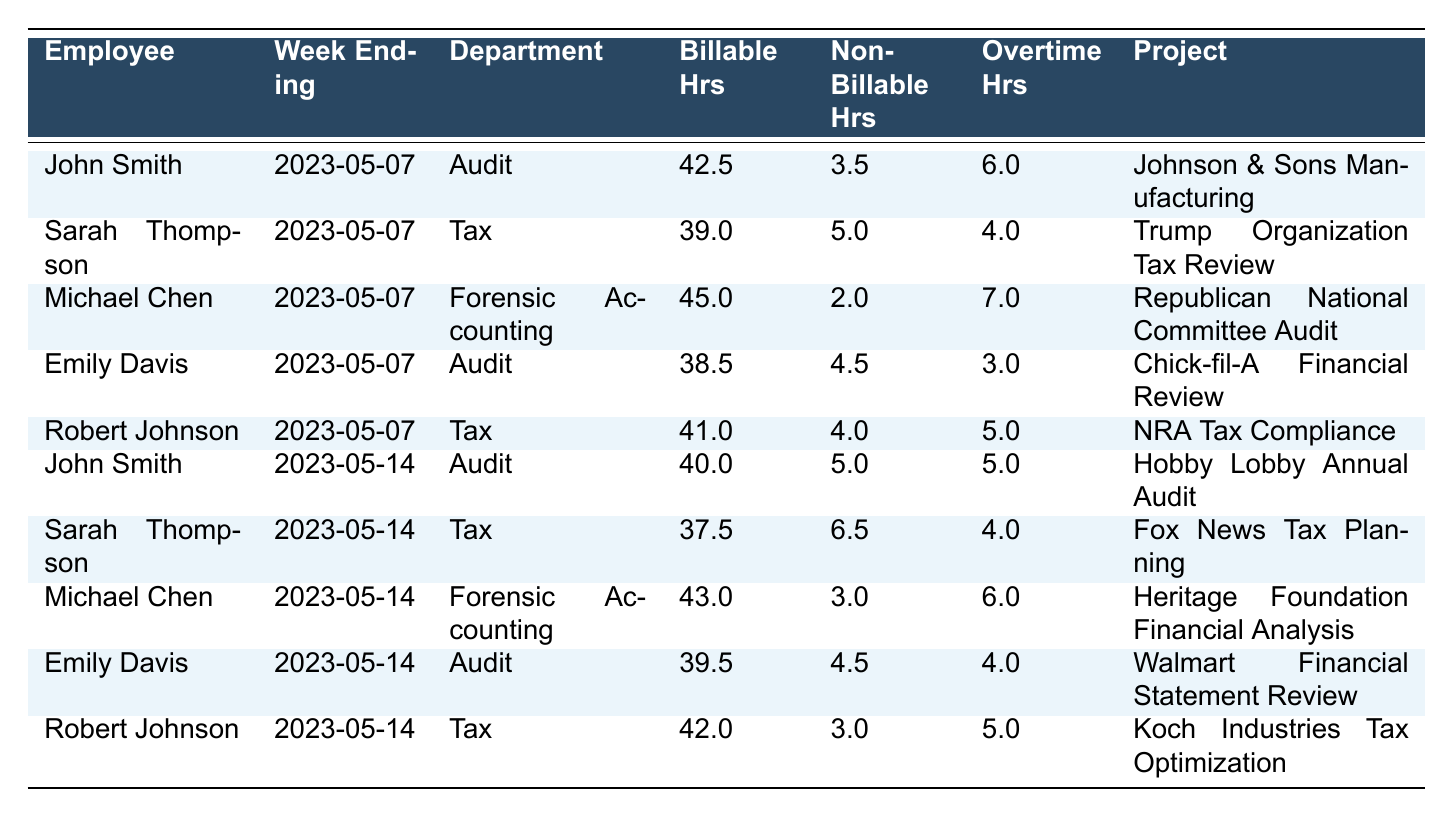What is the total number of billable hours for John Smith across both weeks? From the table, John Smith's billable hours for the week ending on May 7 is 42.5, and for the week ending on May 14, it is 40.0. Adding these together gives us 42.5 + 40.0 = 82.5.
Answer: 82.5 Which employee worked the most non-billable hours in the week ending May 7? Looking at the table for the week ending May 7, the non-billable hours for each employee are as follows: John Smith with 3.5, Sarah Thompson with 5.0, Michael Chen with 2.0, Emily Davis with 4.5, and Robert Johnson with 4.0. The highest non-billable hours is 5.0 by Sarah Thompson.
Answer: Sarah Thompson What is the overtime hour difference between Michael Chen and Robert Johnson for the week ending May 14? In the week ending May 14, Michael Chen has 6.0 overtime hours and Robert Johnson has 5.0. The difference is calculated as 6.0 - 5.0 = 1.0.
Answer: 1.0 On which project did Emily Davis work the least billable hours? Emily Davis worked on two projects: Chick-fil-A Financial Review with 38.5 billable hours and Walmart Financial Statement Review with 39.5 billable hours. Since 38.5 is less than 39.5, she worked the least hours on Chick-fil-A Financial Review.
Answer: Chick-fil-A Financial Review Are the total number of billable hours for Sarah Thompson in both weeks greater than that of Robert Johnson? Sarah Thompson's total billable hours are 39.0 (week ending May 7) + 37.5 (week ending May 14) = 76.5. Robert Johnson's total is 41.0 (week ending May 7) + 42.0 (week ending May 14) = 83.0. Comparing these totals shows that 76.5 is less than 83.0, so the statement is false.
Answer: No What is the average billable hours for the employees in the Audit department over both weeks? For the Audit department, the billable hours over both weeks are: John Smith with 42.5 and 40.0, Emily Davis with 38.5 and 39.5. The total is 42.5 + 40.0 + 38.5 + 39.5 = 160.0. There are four entries, so the average is 160.0 / 4 = 40.0.
Answer: 40.0 What is the total overtime hours worked by all employees in the Tax department over the two weeks? For the week ending May 7, Sarah Thompson has 4.0 overtime hours and Robert Johnson has 5.0. For the week ending May 14, Sarah Thompson has 4.0 and Robert Johnson has 5.0. Summing these gives: (4.0 + 5.0) + (4.0 + 5.0) = 18.0.
Answer: 18.0 Which employee had the highest total hours (billable + non-billable + overtime) for the week ending May 14? For the week ending May 14, calculate the total hours for each employee: John Smith - 40.0 + 5.0 + 5.0 = 50.0, Sarah Thompson - 37.5 + 6.5 + 4.0 = 48.0, Michael Chen - 43.0 + 3.0 + 6.0 = 52.0, Emily Davis - 39.5 + 4.5 + 4.0 = 48.0, Robert Johnson - 42.0 + 3.0 + 5.0 = 50.0. Michael Chen has the highest total at 52.0.
Answer: Michael Chen 